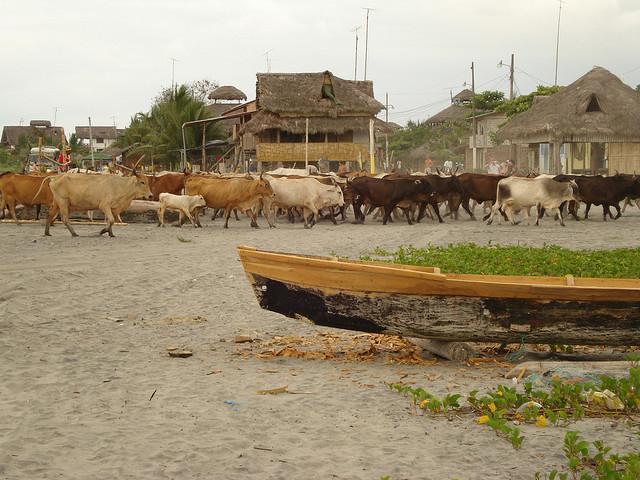How many cows can you see?
Give a very brief answer. 5. 